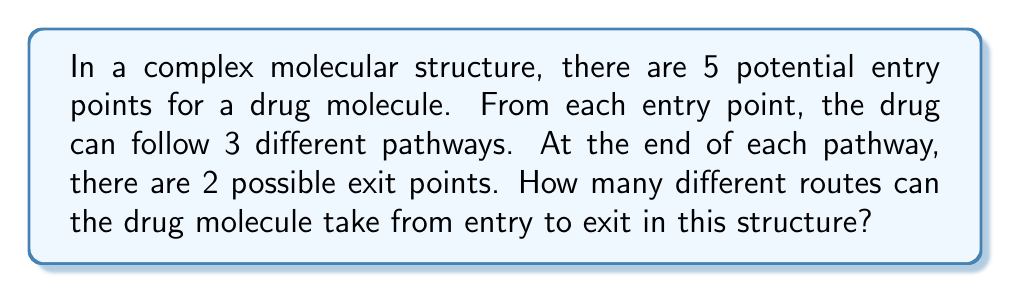Show me your answer to this math problem. Let's break this problem down step-by-step:

1) First, we need to consider the choices at each stage:
   - There are 5 entry points
   - From each entry point, there are 3 pathways
   - Each pathway ends with 2 possible exit points

2) This scenario follows the multiplication principle of counting. We multiply the number of choices at each stage to get the total number of possible outcomes.

3) Let's represent this mathematically:
   $$ \text{Total routes} = \text{Entry points} \times \text{Pathways per entry} \times \text{Exit points per pathway} $$

4) Substituting the values:
   $$ \text{Total routes} = 5 \times 3 \times 2 $$

5) Calculating:
   $$ \text{Total routes} = 30 $$

This problem is relevant to pharmacy as it models how a drug molecule might navigate through a complex biological structure, such as a cell or organ, which is crucial knowledge for drug delivery systems.
Answer: $30$ possible routes 